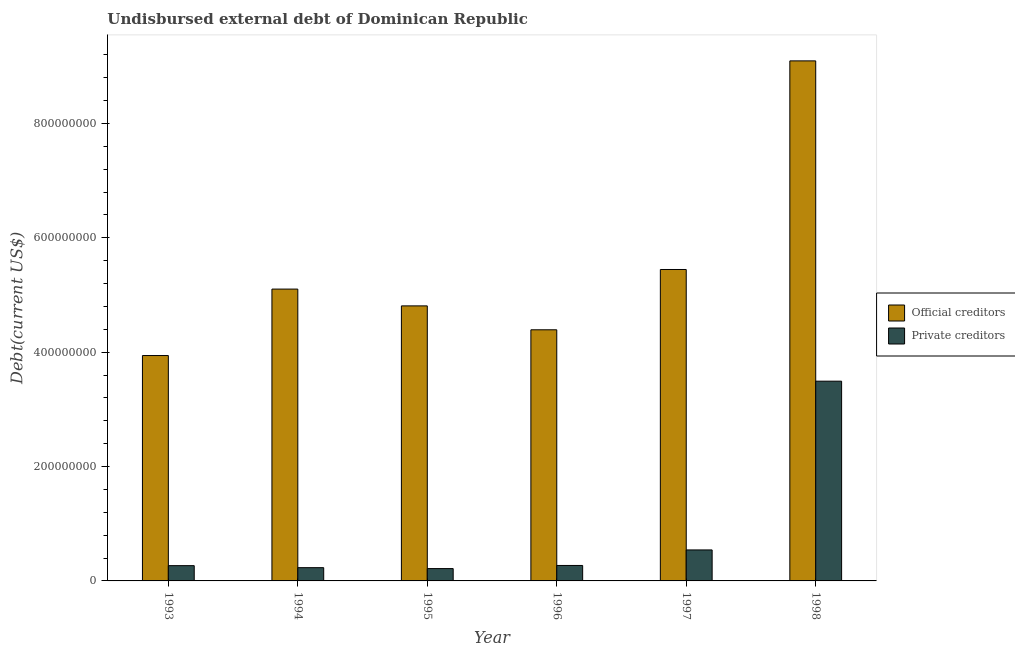Are the number of bars per tick equal to the number of legend labels?
Make the answer very short. Yes. How many bars are there on the 5th tick from the right?
Your answer should be compact. 2. What is the undisbursed external debt of private creditors in 1995?
Make the answer very short. 2.16e+07. Across all years, what is the maximum undisbursed external debt of private creditors?
Keep it short and to the point. 3.49e+08. Across all years, what is the minimum undisbursed external debt of private creditors?
Your answer should be compact. 2.16e+07. In which year was the undisbursed external debt of official creditors minimum?
Offer a very short reply. 1993. What is the total undisbursed external debt of private creditors in the graph?
Offer a very short reply. 5.02e+08. What is the difference between the undisbursed external debt of official creditors in 1996 and that in 1997?
Offer a very short reply. -1.05e+08. What is the difference between the undisbursed external debt of private creditors in 1994 and the undisbursed external debt of official creditors in 1995?
Your answer should be very brief. 1.61e+06. What is the average undisbursed external debt of official creditors per year?
Offer a very short reply. 5.46e+08. In how many years, is the undisbursed external debt of official creditors greater than 160000000 US$?
Provide a short and direct response. 6. What is the ratio of the undisbursed external debt of official creditors in 1993 to that in 1995?
Your answer should be very brief. 0.82. Is the difference between the undisbursed external debt of official creditors in 1994 and 1996 greater than the difference between the undisbursed external debt of private creditors in 1994 and 1996?
Your answer should be compact. No. What is the difference between the highest and the second highest undisbursed external debt of official creditors?
Offer a very short reply. 3.65e+08. What is the difference between the highest and the lowest undisbursed external debt of private creditors?
Provide a short and direct response. 3.28e+08. What does the 1st bar from the left in 1993 represents?
Offer a terse response. Official creditors. What does the 2nd bar from the right in 1998 represents?
Your response must be concise. Official creditors. How many bars are there?
Make the answer very short. 12. Are the values on the major ticks of Y-axis written in scientific E-notation?
Offer a terse response. No. How many legend labels are there?
Offer a very short reply. 2. How are the legend labels stacked?
Give a very brief answer. Vertical. What is the title of the graph?
Offer a terse response. Undisbursed external debt of Dominican Republic. What is the label or title of the Y-axis?
Your response must be concise. Debt(current US$). What is the Debt(current US$) of Official creditors in 1993?
Provide a short and direct response. 3.94e+08. What is the Debt(current US$) in Private creditors in 1993?
Provide a short and direct response. 2.67e+07. What is the Debt(current US$) in Official creditors in 1994?
Offer a terse response. 5.10e+08. What is the Debt(current US$) of Private creditors in 1994?
Provide a short and direct response. 2.32e+07. What is the Debt(current US$) in Official creditors in 1995?
Keep it short and to the point. 4.81e+08. What is the Debt(current US$) in Private creditors in 1995?
Keep it short and to the point. 2.16e+07. What is the Debt(current US$) of Official creditors in 1996?
Keep it short and to the point. 4.39e+08. What is the Debt(current US$) of Private creditors in 1996?
Provide a succinct answer. 2.70e+07. What is the Debt(current US$) in Official creditors in 1997?
Your response must be concise. 5.45e+08. What is the Debt(current US$) of Private creditors in 1997?
Give a very brief answer. 5.42e+07. What is the Debt(current US$) in Official creditors in 1998?
Give a very brief answer. 9.09e+08. What is the Debt(current US$) of Private creditors in 1998?
Provide a succinct answer. 3.49e+08. Across all years, what is the maximum Debt(current US$) of Official creditors?
Your answer should be compact. 9.09e+08. Across all years, what is the maximum Debt(current US$) in Private creditors?
Ensure brevity in your answer.  3.49e+08. Across all years, what is the minimum Debt(current US$) in Official creditors?
Give a very brief answer. 3.94e+08. Across all years, what is the minimum Debt(current US$) of Private creditors?
Offer a terse response. 2.16e+07. What is the total Debt(current US$) of Official creditors in the graph?
Give a very brief answer. 3.28e+09. What is the total Debt(current US$) of Private creditors in the graph?
Your answer should be very brief. 5.02e+08. What is the difference between the Debt(current US$) in Official creditors in 1993 and that in 1994?
Provide a succinct answer. -1.16e+08. What is the difference between the Debt(current US$) of Private creditors in 1993 and that in 1994?
Offer a terse response. 3.52e+06. What is the difference between the Debt(current US$) of Official creditors in 1993 and that in 1995?
Your answer should be compact. -8.68e+07. What is the difference between the Debt(current US$) of Private creditors in 1993 and that in 1995?
Your answer should be compact. 5.14e+06. What is the difference between the Debt(current US$) of Official creditors in 1993 and that in 1996?
Provide a succinct answer. -4.50e+07. What is the difference between the Debt(current US$) in Private creditors in 1993 and that in 1996?
Give a very brief answer. -3.25e+05. What is the difference between the Debt(current US$) in Official creditors in 1993 and that in 1997?
Offer a terse response. -1.50e+08. What is the difference between the Debt(current US$) of Private creditors in 1993 and that in 1997?
Make the answer very short. -2.75e+07. What is the difference between the Debt(current US$) of Official creditors in 1993 and that in 1998?
Your response must be concise. -5.15e+08. What is the difference between the Debt(current US$) in Private creditors in 1993 and that in 1998?
Your response must be concise. -3.23e+08. What is the difference between the Debt(current US$) in Official creditors in 1994 and that in 1995?
Your answer should be compact. 2.94e+07. What is the difference between the Debt(current US$) of Private creditors in 1994 and that in 1995?
Offer a terse response. 1.61e+06. What is the difference between the Debt(current US$) in Official creditors in 1994 and that in 1996?
Ensure brevity in your answer.  7.12e+07. What is the difference between the Debt(current US$) of Private creditors in 1994 and that in 1996?
Keep it short and to the point. -3.85e+06. What is the difference between the Debt(current US$) in Official creditors in 1994 and that in 1997?
Provide a short and direct response. -3.43e+07. What is the difference between the Debt(current US$) of Private creditors in 1994 and that in 1997?
Make the answer very short. -3.10e+07. What is the difference between the Debt(current US$) in Official creditors in 1994 and that in 1998?
Your answer should be compact. -3.99e+08. What is the difference between the Debt(current US$) of Private creditors in 1994 and that in 1998?
Ensure brevity in your answer.  -3.26e+08. What is the difference between the Debt(current US$) in Official creditors in 1995 and that in 1996?
Give a very brief answer. 4.18e+07. What is the difference between the Debt(current US$) of Private creditors in 1995 and that in 1996?
Ensure brevity in your answer.  -5.46e+06. What is the difference between the Debt(current US$) of Official creditors in 1995 and that in 1997?
Offer a very short reply. -6.36e+07. What is the difference between the Debt(current US$) of Private creditors in 1995 and that in 1997?
Your answer should be very brief. -3.26e+07. What is the difference between the Debt(current US$) of Official creditors in 1995 and that in 1998?
Your answer should be compact. -4.28e+08. What is the difference between the Debt(current US$) in Private creditors in 1995 and that in 1998?
Provide a succinct answer. -3.28e+08. What is the difference between the Debt(current US$) in Official creditors in 1996 and that in 1997?
Your answer should be very brief. -1.05e+08. What is the difference between the Debt(current US$) of Private creditors in 1996 and that in 1997?
Your answer should be compact. -2.72e+07. What is the difference between the Debt(current US$) of Official creditors in 1996 and that in 1998?
Provide a short and direct response. -4.70e+08. What is the difference between the Debt(current US$) of Private creditors in 1996 and that in 1998?
Offer a very short reply. -3.22e+08. What is the difference between the Debt(current US$) in Official creditors in 1997 and that in 1998?
Offer a very short reply. -3.65e+08. What is the difference between the Debt(current US$) in Private creditors in 1997 and that in 1998?
Keep it short and to the point. -2.95e+08. What is the difference between the Debt(current US$) in Official creditors in 1993 and the Debt(current US$) in Private creditors in 1994?
Keep it short and to the point. 3.71e+08. What is the difference between the Debt(current US$) of Official creditors in 1993 and the Debt(current US$) of Private creditors in 1995?
Your answer should be compact. 3.73e+08. What is the difference between the Debt(current US$) in Official creditors in 1993 and the Debt(current US$) in Private creditors in 1996?
Your answer should be compact. 3.67e+08. What is the difference between the Debt(current US$) of Official creditors in 1993 and the Debt(current US$) of Private creditors in 1997?
Your response must be concise. 3.40e+08. What is the difference between the Debt(current US$) of Official creditors in 1993 and the Debt(current US$) of Private creditors in 1998?
Make the answer very short. 4.48e+07. What is the difference between the Debt(current US$) in Official creditors in 1994 and the Debt(current US$) in Private creditors in 1995?
Your answer should be compact. 4.89e+08. What is the difference between the Debt(current US$) in Official creditors in 1994 and the Debt(current US$) in Private creditors in 1996?
Offer a terse response. 4.83e+08. What is the difference between the Debt(current US$) of Official creditors in 1994 and the Debt(current US$) of Private creditors in 1997?
Provide a short and direct response. 4.56e+08. What is the difference between the Debt(current US$) of Official creditors in 1994 and the Debt(current US$) of Private creditors in 1998?
Your response must be concise. 1.61e+08. What is the difference between the Debt(current US$) in Official creditors in 1995 and the Debt(current US$) in Private creditors in 1996?
Offer a terse response. 4.54e+08. What is the difference between the Debt(current US$) in Official creditors in 1995 and the Debt(current US$) in Private creditors in 1997?
Keep it short and to the point. 4.27e+08. What is the difference between the Debt(current US$) in Official creditors in 1995 and the Debt(current US$) in Private creditors in 1998?
Your answer should be very brief. 1.32e+08. What is the difference between the Debt(current US$) in Official creditors in 1996 and the Debt(current US$) in Private creditors in 1997?
Keep it short and to the point. 3.85e+08. What is the difference between the Debt(current US$) in Official creditors in 1996 and the Debt(current US$) in Private creditors in 1998?
Your answer should be compact. 8.99e+07. What is the difference between the Debt(current US$) of Official creditors in 1997 and the Debt(current US$) of Private creditors in 1998?
Your answer should be very brief. 1.95e+08. What is the average Debt(current US$) in Official creditors per year?
Keep it short and to the point. 5.46e+08. What is the average Debt(current US$) in Private creditors per year?
Your answer should be very brief. 8.37e+07. In the year 1993, what is the difference between the Debt(current US$) in Official creditors and Debt(current US$) in Private creditors?
Your answer should be very brief. 3.67e+08. In the year 1994, what is the difference between the Debt(current US$) in Official creditors and Debt(current US$) in Private creditors?
Provide a short and direct response. 4.87e+08. In the year 1995, what is the difference between the Debt(current US$) of Official creditors and Debt(current US$) of Private creditors?
Make the answer very short. 4.59e+08. In the year 1996, what is the difference between the Debt(current US$) in Official creditors and Debt(current US$) in Private creditors?
Make the answer very short. 4.12e+08. In the year 1997, what is the difference between the Debt(current US$) of Official creditors and Debt(current US$) of Private creditors?
Provide a short and direct response. 4.90e+08. In the year 1998, what is the difference between the Debt(current US$) of Official creditors and Debt(current US$) of Private creditors?
Offer a terse response. 5.60e+08. What is the ratio of the Debt(current US$) in Official creditors in 1993 to that in 1994?
Offer a very short reply. 0.77. What is the ratio of the Debt(current US$) of Private creditors in 1993 to that in 1994?
Your answer should be compact. 1.15. What is the ratio of the Debt(current US$) in Official creditors in 1993 to that in 1995?
Ensure brevity in your answer.  0.82. What is the ratio of the Debt(current US$) of Private creditors in 1993 to that in 1995?
Offer a terse response. 1.24. What is the ratio of the Debt(current US$) in Official creditors in 1993 to that in 1996?
Give a very brief answer. 0.9. What is the ratio of the Debt(current US$) in Official creditors in 1993 to that in 1997?
Make the answer very short. 0.72. What is the ratio of the Debt(current US$) of Private creditors in 1993 to that in 1997?
Provide a succinct answer. 0.49. What is the ratio of the Debt(current US$) in Official creditors in 1993 to that in 1998?
Provide a succinct answer. 0.43. What is the ratio of the Debt(current US$) in Private creditors in 1993 to that in 1998?
Ensure brevity in your answer.  0.08. What is the ratio of the Debt(current US$) of Official creditors in 1994 to that in 1995?
Provide a short and direct response. 1.06. What is the ratio of the Debt(current US$) of Private creditors in 1994 to that in 1995?
Your answer should be compact. 1.07. What is the ratio of the Debt(current US$) in Official creditors in 1994 to that in 1996?
Provide a short and direct response. 1.16. What is the ratio of the Debt(current US$) of Private creditors in 1994 to that in 1996?
Your answer should be compact. 0.86. What is the ratio of the Debt(current US$) in Official creditors in 1994 to that in 1997?
Your answer should be very brief. 0.94. What is the ratio of the Debt(current US$) of Private creditors in 1994 to that in 1997?
Make the answer very short. 0.43. What is the ratio of the Debt(current US$) in Official creditors in 1994 to that in 1998?
Your answer should be very brief. 0.56. What is the ratio of the Debt(current US$) of Private creditors in 1994 to that in 1998?
Your response must be concise. 0.07. What is the ratio of the Debt(current US$) in Official creditors in 1995 to that in 1996?
Give a very brief answer. 1.1. What is the ratio of the Debt(current US$) in Private creditors in 1995 to that in 1996?
Your answer should be compact. 0.8. What is the ratio of the Debt(current US$) of Official creditors in 1995 to that in 1997?
Make the answer very short. 0.88. What is the ratio of the Debt(current US$) in Private creditors in 1995 to that in 1997?
Your answer should be compact. 0.4. What is the ratio of the Debt(current US$) in Official creditors in 1995 to that in 1998?
Your response must be concise. 0.53. What is the ratio of the Debt(current US$) in Private creditors in 1995 to that in 1998?
Ensure brevity in your answer.  0.06. What is the ratio of the Debt(current US$) of Official creditors in 1996 to that in 1997?
Your response must be concise. 0.81. What is the ratio of the Debt(current US$) of Private creditors in 1996 to that in 1997?
Give a very brief answer. 0.5. What is the ratio of the Debt(current US$) in Official creditors in 1996 to that in 1998?
Your response must be concise. 0.48. What is the ratio of the Debt(current US$) in Private creditors in 1996 to that in 1998?
Your answer should be compact. 0.08. What is the ratio of the Debt(current US$) of Official creditors in 1997 to that in 1998?
Offer a very short reply. 0.6. What is the ratio of the Debt(current US$) of Private creditors in 1997 to that in 1998?
Your answer should be very brief. 0.16. What is the difference between the highest and the second highest Debt(current US$) in Official creditors?
Keep it short and to the point. 3.65e+08. What is the difference between the highest and the second highest Debt(current US$) of Private creditors?
Your answer should be compact. 2.95e+08. What is the difference between the highest and the lowest Debt(current US$) of Official creditors?
Provide a short and direct response. 5.15e+08. What is the difference between the highest and the lowest Debt(current US$) of Private creditors?
Make the answer very short. 3.28e+08. 